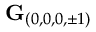Convert formula to latex. <formula><loc_0><loc_0><loc_500><loc_500>G _ { ( 0 , 0 , 0 , \pm 1 ) }</formula> 